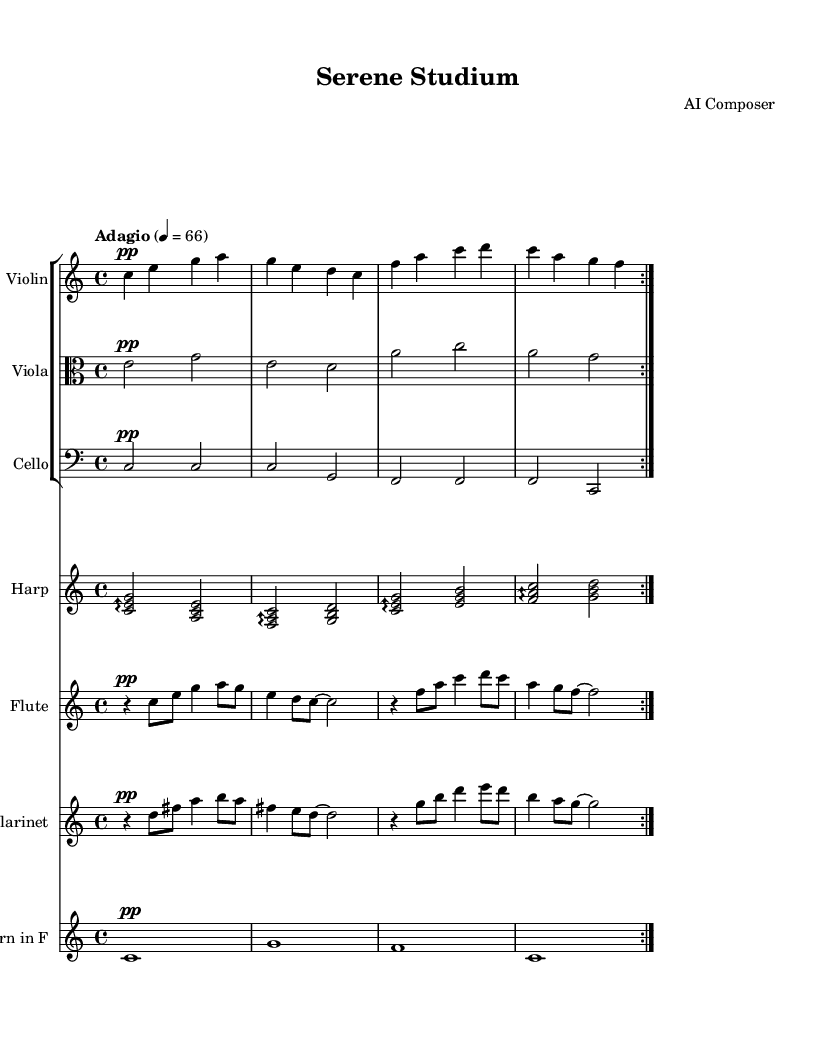What is the key signature of this music? The key signature is indicated at the beginning of the piece. Since it shows no sharps or flats, it confirms that the key signature is C major.
Answer: C major What is the time signature of this music? The time signature is placed before the notes at the beginning. It shows "4/4", indicating there are four beats in each measure.
Answer: 4/4 What is the tempo marking of this piece? The tempo marking is noted in a section at the beginning. It states "Adagio" with a metronome marking of 66 beats per minute, indicating a slow pace.
Answer: Adagio, 66 How many instruments are featured in this piece? The score section lists six separate staves, indicating six different instruments in total: Violin, Viola, Cello, Harp, Flute, Clarinet, and Horn in F.
Answer: Six instruments Which instrument plays in the highest register? By comparing the clefs and the notes for each instrument, the Flute, which uses a treble clef and tends to play higher notes, plays in the highest register.
Answer: Flute What dynamics are indicated for the Violin part? The dynamic marking for the Violin section is shown at the beginning of its staff as "pp" (pianissimo), meaning it should be played very softly throughout the piece.
Answer: pp In what type of style is this music particularly composed? The piece is described as an ambient orchestral work, aimed to be soothing and conducive for study. The harmonic and melodic choices enhance a tranquil atmosphere.
Answer: Ambient orchestral 